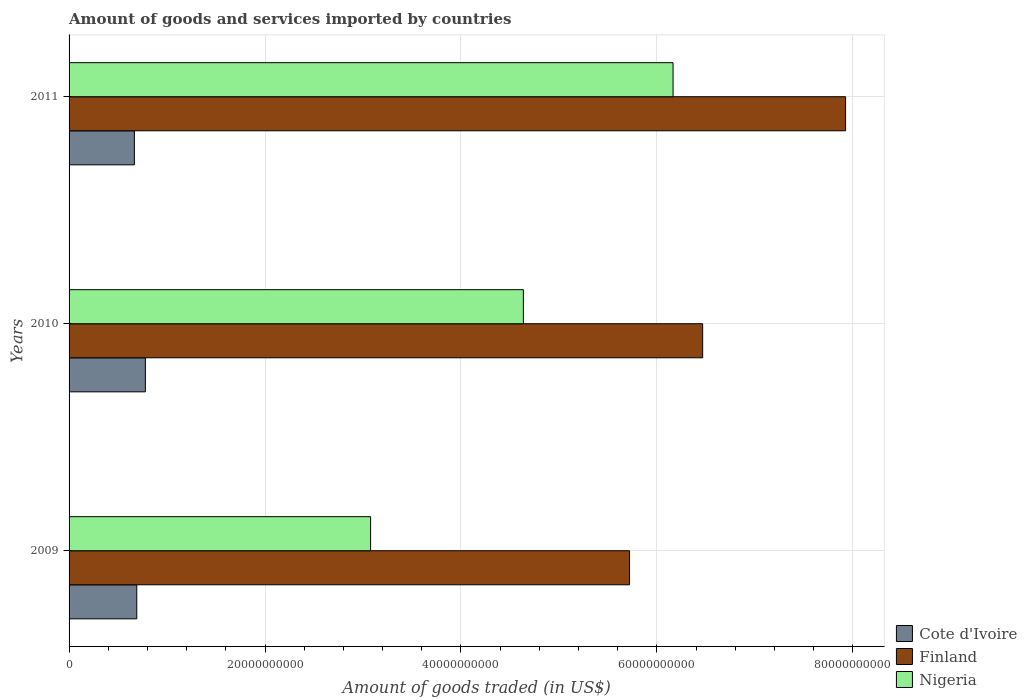How many different coloured bars are there?
Provide a succinct answer. 3. Are the number of bars per tick equal to the number of legend labels?
Your answer should be very brief. Yes. Are the number of bars on each tick of the Y-axis equal?
Provide a succinct answer. Yes. How many bars are there on the 1st tick from the bottom?
Keep it short and to the point. 3. What is the label of the 3rd group of bars from the top?
Give a very brief answer. 2009. In how many cases, is the number of bars for a given year not equal to the number of legend labels?
Your answer should be compact. 0. What is the total amount of goods and services imported in Finland in 2009?
Offer a terse response. 5.72e+1. Across all years, what is the maximum total amount of goods and services imported in Finland?
Offer a terse response. 7.93e+1. Across all years, what is the minimum total amount of goods and services imported in Cote d'Ivoire?
Ensure brevity in your answer.  6.67e+09. In which year was the total amount of goods and services imported in Nigeria minimum?
Provide a succinct answer. 2009. What is the total total amount of goods and services imported in Nigeria in the graph?
Provide a short and direct response. 1.39e+11. What is the difference between the total amount of goods and services imported in Nigeria in 2010 and that in 2011?
Provide a short and direct response. -1.53e+1. What is the difference between the total amount of goods and services imported in Finland in 2010 and the total amount of goods and services imported in Cote d'Ivoire in 2011?
Ensure brevity in your answer.  5.80e+1. What is the average total amount of goods and services imported in Finland per year?
Your response must be concise. 6.71e+1. In the year 2011, what is the difference between the total amount of goods and services imported in Finland and total amount of goods and services imported in Cote d'Ivoire?
Ensure brevity in your answer.  7.26e+1. What is the ratio of the total amount of goods and services imported in Nigeria in 2009 to that in 2010?
Your response must be concise. 0.66. Is the total amount of goods and services imported in Cote d'Ivoire in 2009 less than that in 2010?
Give a very brief answer. Yes. What is the difference between the highest and the second highest total amount of goods and services imported in Finland?
Ensure brevity in your answer.  1.46e+1. What is the difference between the highest and the lowest total amount of goods and services imported in Cote d'Ivoire?
Ensure brevity in your answer.  1.12e+09. In how many years, is the total amount of goods and services imported in Cote d'Ivoire greater than the average total amount of goods and services imported in Cote d'Ivoire taken over all years?
Provide a succinct answer. 1. What does the 1st bar from the top in 2009 represents?
Ensure brevity in your answer.  Nigeria. How many bars are there?
Keep it short and to the point. 9. Are all the bars in the graph horizontal?
Offer a terse response. Yes. Are the values on the major ticks of X-axis written in scientific E-notation?
Ensure brevity in your answer.  No. Does the graph contain any zero values?
Your answer should be compact. No. Where does the legend appear in the graph?
Offer a terse response. Bottom right. How are the legend labels stacked?
Offer a very short reply. Vertical. What is the title of the graph?
Your answer should be very brief. Amount of goods and services imported by countries. What is the label or title of the X-axis?
Your response must be concise. Amount of goods traded (in US$). What is the Amount of goods traded (in US$) in Cote d'Ivoire in 2009?
Your response must be concise. 6.91e+09. What is the Amount of goods traded (in US$) of Finland in 2009?
Provide a succinct answer. 5.72e+1. What is the Amount of goods traded (in US$) in Nigeria in 2009?
Keep it short and to the point. 3.08e+1. What is the Amount of goods traded (in US$) in Cote d'Ivoire in 2010?
Ensure brevity in your answer.  7.79e+09. What is the Amount of goods traded (in US$) of Finland in 2010?
Provide a succinct answer. 6.47e+1. What is the Amount of goods traded (in US$) of Nigeria in 2010?
Keep it short and to the point. 4.64e+1. What is the Amount of goods traded (in US$) of Cote d'Ivoire in 2011?
Provide a succinct answer. 6.67e+09. What is the Amount of goods traded (in US$) of Finland in 2011?
Give a very brief answer. 7.93e+1. What is the Amount of goods traded (in US$) in Nigeria in 2011?
Make the answer very short. 6.17e+1. Across all years, what is the maximum Amount of goods traded (in US$) of Cote d'Ivoire?
Ensure brevity in your answer.  7.79e+09. Across all years, what is the maximum Amount of goods traded (in US$) of Finland?
Your response must be concise. 7.93e+1. Across all years, what is the maximum Amount of goods traded (in US$) of Nigeria?
Keep it short and to the point. 6.17e+1. Across all years, what is the minimum Amount of goods traded (in US$) in Cote d'Ivoire?
Keep it short and to the point. 6.67e+09. Across all years, what is the minimum Amount of goods traded (in US$) in Finland?
Provide a short and direct response. 5.72e+1. Across all years, what is the minimum Amount of goods traded (in US$) in Nigeria?
Offer a terse response. 3.08e+1. What is the total Amount of goods traded (in US$) of Cote d'Ivoire in the graph?
Provide a succinct answer. 2.14e+1. What is the total Amount of goods traded (in US$) in Finland in the graph?
Make the answer very short. 2.01e+11. What is the total Amount of goods traded (in US$) of Nigeria in the graph?
Offer a terse response. 1.39e+11. What is the difference between the Amount of goods traded (in US$) of Cote d'Ivoire in 2009 and that in 2010?
Ensure brevity in your answer.  -8.77e+08. What is the difference between the Amount of goods traded (in US$) of Finland in 2009 and that in 2010?
Give a very brief answer. -7.46e+09. What is the difference between the Amount of goods traded (in US$) of Nigeria in 2009 and that in 2010?
Make the answer very short. -1.56e+1. What is the difference between the Amount of goods traded (in US$) in Cote d'Ivoire in 2009 and that in 2011?
Your answer should be very brief. 2.45e+08. What is the difference between the Amount of goods traded (in US$) in Finland in 2009 and that in 2011?
Your response must be concise. -2.21e+1. What is the difference between the Amount of goods traded (in US$) in Nigeria in 2009 and that in 2011?
Ensure brevity in your answer.  -3.09e+1. What is the difference between the Amount of goods traded (in US$) in Cote d'Ivoire in 2010 and that in 2011?
Provide a short and direct response. 1.12e+09. What is the difference between the Amount of goods traded (in US$) in Finland in 2010 and that in 2011?
Make the answer very short. -1.46e+1. What is the difference between the Amount of goods traded (in US$) of Nigeria in 2010 and that in 2011?
Keep it short and to the point. -1.53e+1. What is the difference between the Amount of goods traded (in US$) in Cote d'Ivoire in 2009 and the Amount of goods traded (in US$) in Finland in 2010?
Give a very brief answer. -5.78e+1. What is the difference between the Amount of goods traded (in US$) in Cote d'Ivoire in 2009 and the Amount of goods traded (in US$) in Nigeria in 2010?
Make the answer very short. -3.95e+1. What is the difference between the Amount of goods traded (in US$) of Finland in 2009 and the Amount of goods traded (in US$) of Nigeria in 2010?
Make the answer very short. 1.08e+1. What is the difference between the Amount of goods traded (in US$) in Cote d'Ivoire in 2009 and the Amount of goods traded (in US$) in Finland in 2011?
Offer a terse response. -7.24e+1. What is the difference between the Amount of goods traded (in US$) in Cote d'Ivoire in 2009 and the Amount of goods traded (in US$) in Nigeria in 2011?
Ensure brevity in your answer.  -5.47e+1. What is the difference between the Amount of goods traded (in US$) in Finland in 2009 and the Amount of goods traded (in US$) in Nigeria in 2011?
Your response must be concise. -4.44e+09. What is the difference between the Amount of goods traded (in US$) in Cote d'Ivoire in 2010 and the Amount of goods traded (in US$) in Finland in 2011?
Offer a terse response. -7.15e+1. What is the difference between the Amount of goods traded (in US$) of Cote d'Ivoire in 2010 and the Amount of goods traded (in US$) of Nigeria in 2011?
Keep it short and to the point. -5.39e+1. What is the difference between the Amount of goods traded (in US$) in Finland in 2010 and the Amount of goods traded (in US$) in Nigeria in 2011?
Your answer should be very brief. 3.02e+09. What is the average Amount of goods traded (in US$) in Cote d'Ivoire per year?
Give a very brief answer. 7.12e+09. What is the average Amount of goods traded (in US$) of Finland per year?
Provide a succinct answer. 6.71e+1. What is the average Amount of goods traded (in US$) of Nigeria per year?
Ensure brevity in your answer.  4.63e+1. In the year 2009, what is the difference between the Amount of goods traded (in US$) in Cote d'Ivoire and Amount of goods traded (in US$) in Finland?
Make the answer very short. -5.03e+1. In the year 2009, what is the difference between the Amount of goods traded (in US$) of Cote d'Ivoire and Amount of goods traded (in US$) of Nigeria?
Your response must be concise. -2.39e+1. In the year 2009, what is the difference between the Amount of goods traded (in US$) in Finland and Amount of goods traded (in US$) in Nigeria?
Offer a terse response. 2.64e+1. In the year 2010, what is the difference between the Amount of goods traded (in US$) in Cote d'Ivoire and Amount of goods traded (in US$) in Finland?
Your answer should be very brief. -5.69e+1. In the year 2010, what is the difference between the Amount of goods traded (in US$) in Cote d'Ivoire and Amount of goods traded (in US$) in Nigeria?
Provide a short and direct response. -3.86e+1. In the year 2010, what is the difference between the Amount of goods traded (in US$) in Finland and Amount of goods traded (in US$) in Nigeria?
Provide a succinct answer. 1.83e+1. In the year 2011, what is the difference between the Amount of goods traded (in US$) of Cote d'Ivoire and Amount of goods traded (in US$) of Finland?
Offer a very short reply. -7.26e+1. In the year 2011, what is the difference between the Amount of goods traded (in US$) in Cote d'Ivoire and Amount of goods traded (in US$) in Nigeria?
Your answer should be compact. -5.50e+1. In the year 2011, what is the difference between the Amount of goods traded (in US$) in Finland and Amount of goods traded (in US$) in Nigeria?
Ensure brevity in your answer.  1.76e+1. What is the ratio of the Amount of goods traded (in US$) in Cote d'Ivoire in 2009 to that in 2010?
Provide a succinct answer. 0.89. What is the ratio of the Amount of goods traded (in US$) in Finland in 2009 to that in 2010?
Keep it short and to the point. 0.88. What is the ratio of the Amount of goods traded (in US$) in Nigeria in 2009 to that in 2010?
Give a very brief answer. 0.66. What is the ratio of the Amount of goods traded (in US$) in Cote d'Ivoire in 2009 to that in 2011?
Provide a short and direct response. 1.04. What is the ratio of the Amount of goods traded (in US$) of Finland in 2009 to that in 2011?
Make the answer very short. 0.72. What is the ratio of the Amount of goods traded (in US$) in Nigeria in 2009 to that in 2011?
Keep it short and to the point. 0.5. What is the ratio of the Amount of goods traded (in US$) of Cote d'Ivoire in 2010 to that in 2011?
Provide a short and direct response. 1.17. What is the ratio of the Amount of goods traded (in US$) in Finland in 2010 to that in 2011?
Give a very brief answer. 0.82. What is the ratio of the Amount of goods traded (in US$) in Nigeria in 2010 to that in 2011?
Keep it short and to the point. 0.75. What is the difference between the highest and the second highest Amount of goods traded (in US$) in Cote d'Ivoire?
Provide a short and direct response. 8.77e+08. What is the difference between the highest and the second highest Amount of goods traded (in US$) in Finland?
Your answer should be very brief. 1.46e+1. What is the difference between the highest and the second highest Amount of goods traded (in US$) of Nigeria?
Provide a succinct answer. 1.53e+1. What is the difference between the highest and the lowest Amount of goods traded (in US$) of Cote d'Ivoire?
Provide a short and direct response. 1.12e+09. What is the difference between the highest and the lowest Amount of goods traded (in US$) in Finland?
Your answer should be compact. 2.21e+1. What is the difference between the highest and the lowest Amount of goods traded (in US$) of Nigeria?
Ensure brevity in your answer.  3.09e+1. 